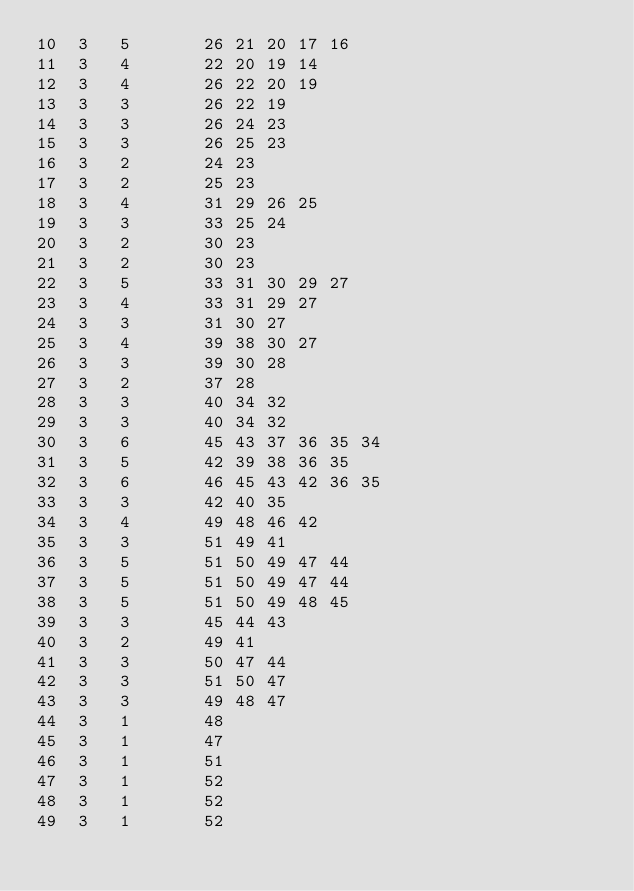Convert code to text. <code><loc_0><loc_0><loc_500><loc_500><_ObjectiveC_>10	3	5		26 21 20 17 16 
11	3	4		22 20 19 14 
12	3	4		26 22 20 19 
13	3	3		26 22 19 
14	3	3		26 24 23 
15	3	3		26 25 23 
16	3	2		24 23 
17	3	2		25 23 
18	3	4		31 29 26 25 
19	3	3		33 25 24 
20	3	2		30 23 
21	3	2		30 23 
22	3	5		33 31 30 29 27 
23	3	4		33 31 29 27 
24	3	3		31 30 27 
25	3	4		39 38 30 27 
26	3	3		39 30 28 
27	3	2		37 28 
28	3	3		40 34 32 
29	3	3		40 34 32 
30	3	6		45 43 37 36 35 34 
31	3	5		42 39 38 36 35 
32	3	6		46 45 43 42 36 35 
33	3	3		42 40 35 
34	3	4		49 48 46 42 
35	3	3		51 49 41 
36	3	5		51 50 49 47 44 
37	3	5		51 50 49 47 44 
38	3	5		51 50 49 48 45 
39	3	3		45 44 43 
40	3	2		49 41 
41	3	3		50 47 44 
42	3	3		51 50 47 
43	3	3		49 48 47 
44	3	1		48 
45	3	1		47 
46	3	1		51 
47	3	1		52 
48	3	1		52 
49	3	1		52 </code> 